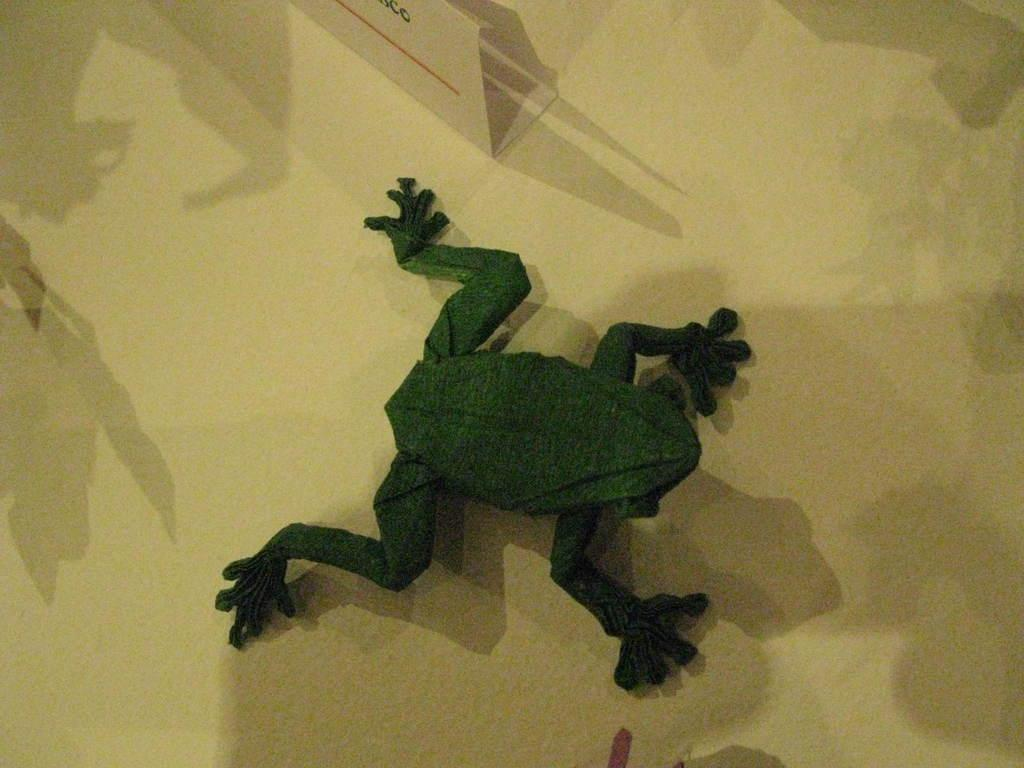What type of building model is depicted in the image? There is a building model of a frog in the image. What type of pizzas are being cooked in the image? There are no pizzas present in the image; it features a building model of a frog. How much steam is visible coming from the frog's mouth in the image? There is no steam visible in the image, as it only features a building model of a frog. 